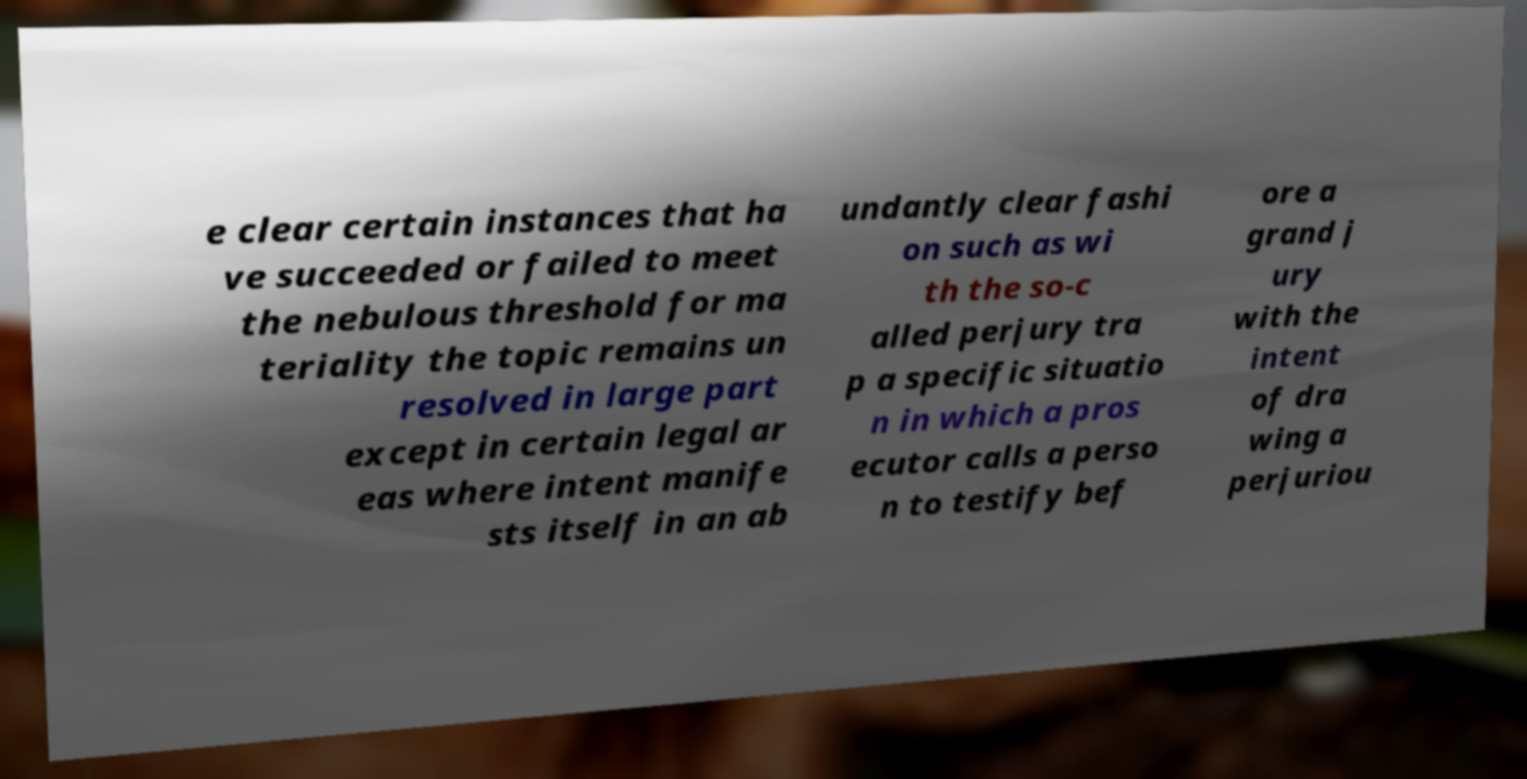Could you assist in decoding the text presented in this image and type it out clearly? e clear certain instances that ha ve succeeded or failed to meet the nebulous threshold for ma teriality the topic remains un resolved in large part except in certain legal ar eas where intent manife sts itself in an ab undantly clear fashi on such as wi th the so-c alled perjury tra p a specific situatio n in which a pros ecutor calls a perso n to testify bef ore a grand j ury with the intent of dra wing a perjuriou 